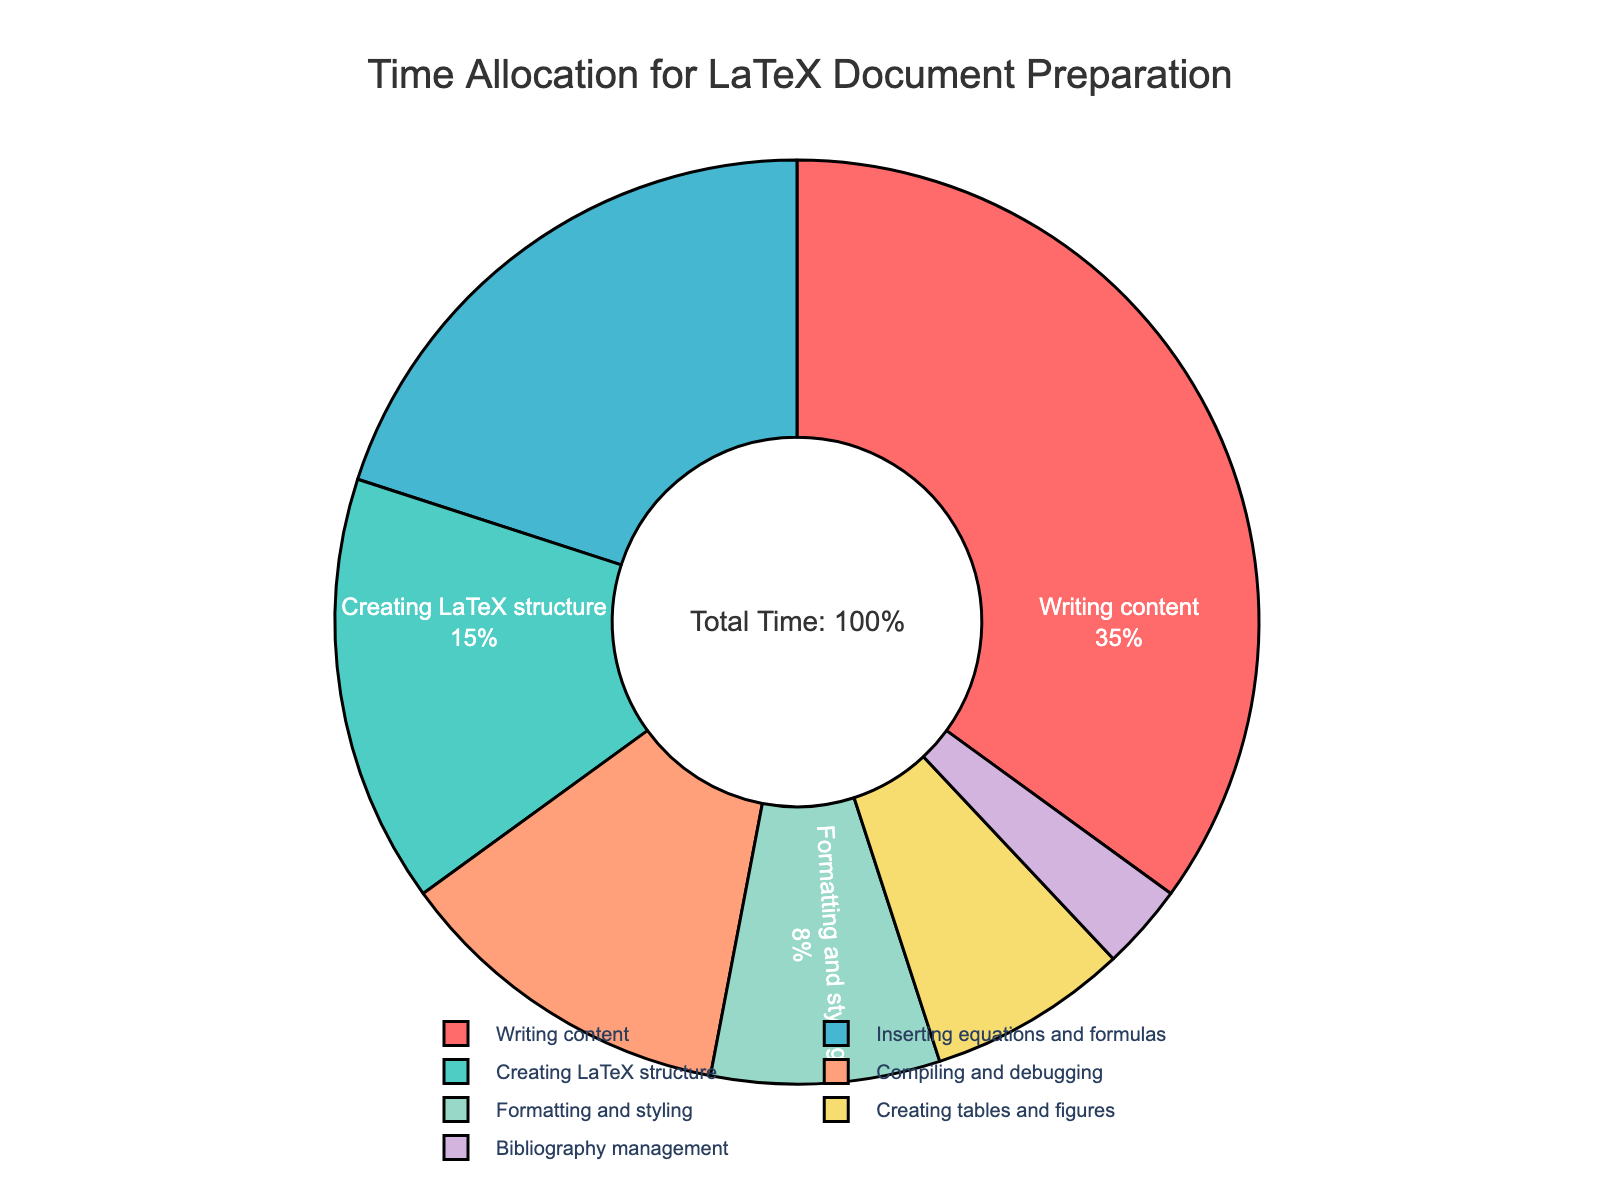What percentage of time is allocated to "Creating LaTeX structure"? By referring to the pie chart, look for the segment labeled "Creating LaTeX structure" to find the percentage value.
Answer: 15% Which stage takes up the most time? Identify the segment of the pie chart with the largest percentage value. The stage with the highest percentage is the one that takes the most time.
Answer: Writing content What is the total percentage of time spent on "Inserting equations and formulas" and "Compiling and debugging"? Add together the percentages for "Inserting equations and formulas" (20%) and "Compiling and debugging" (12%). The sum is 20% + 12% = 32%.
Answer: 32% How does the time allocated to "Formatting and styling" compare to "Creating tables and figures"? Compare the percentages for "Formatting and styling" (8%) and "Creating tables and figures" (7%). 8% is greater than 7%.
Answer: Formatting and styling takes more time Is the percentage of time spent on "Bibliography management" less than 5%? Find the segment labeled "Bibliography management" and observe its percentage value, which is 3%. Since 3% is less than 5%, the answer is yes.
Answer: Yes What percentage of the total time is spent on tasks other than "Writing content"? Subtract the percentage for "Writing content" (35%) from the total (100%). The calculation is 100% - 35% = 65%.
Answer: 65% How much more time is spent on "Inserting equations and formulas" compared to "Creating tables and figures"? Subtract the percentage for "Creating tables and figures" (7%) from "Inserting equations and formulas" (20%). The calculation is 20% - 7% = 13%.
Answer: 13% What is the combined percentage of time for "Formatting and styling" and "Creating tables and figures"? Add together the percentages for "Formatting and styling" (8%) and "Creating tables and figures" (7%). The sum is 8% + 7% = 15%.
Answer: 15% What visual color is used for "Writing content"? Observe the color associated with the "Writing content" segment in the pie chart. It is shown in red.
Answer: Red 